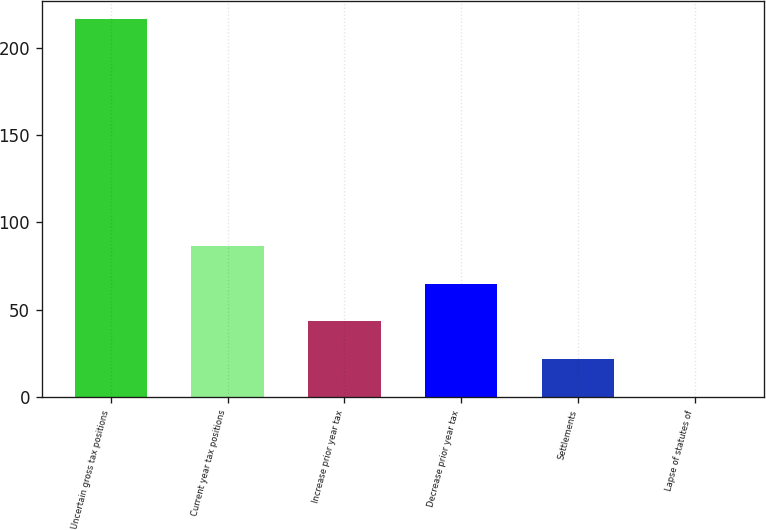<chart> <loc_0><loc_0><loc_500><loc_500><bar_chart><fcel>Uncertain gross tax positions<fcel>Current year tax positions<fcel>Increase prior year tax<fcel>Decrease prior year tax<fcel>Settlements<fcel>Lapse of statutes of<nl><fcel>216.1<fcel>86.56<fcel>43.38<fcel>64.97<fcel>21.79<fcel>0.2<nl></chart> 